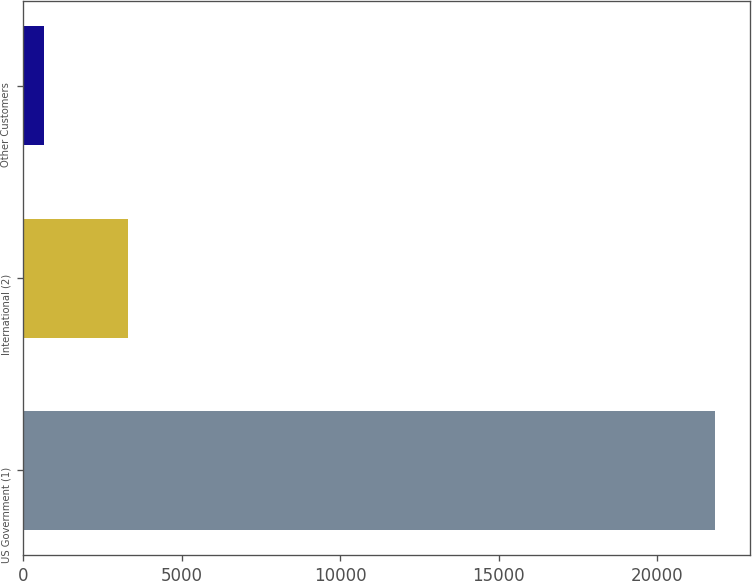Convert chart. <chart><loc_0><loc_0><loc_500><loc_500><bar_chart><fcel>US Government (1)<fcel>International (2)<fcel>Other Customers<nl><fcel>21837<fcel>3302<fcel>664<nl></chart> 